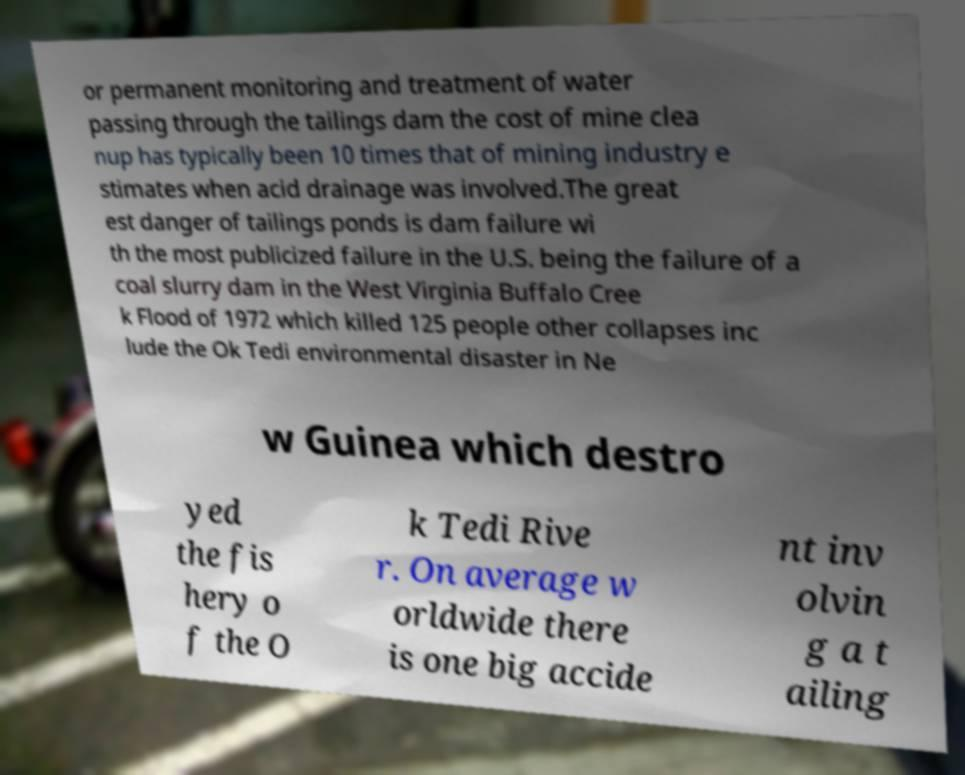For documentation purposes, I need the text within this image transcribed. Could you provide that? or permanent monitoring and treatment of water passing through the tailings dam the cost of mine clea nup has typically been 10 times that of mining industry e stimates when acid drainage was involved.The great est danger of tailings ponds is dam failure wi th the most publicized failure in the U.S. being the failure of a coal slurry dam in the West Virginia Buffalo Cree k Flood of 1972 which killed 125 people other collapses inc lude the Ok Tedi environmental disaster in Ne w Guinea which destro yed the fis hery o f the O k Tedi Rive r. On average w orldwide there is one big accide nt inv olvin g a t ailing 